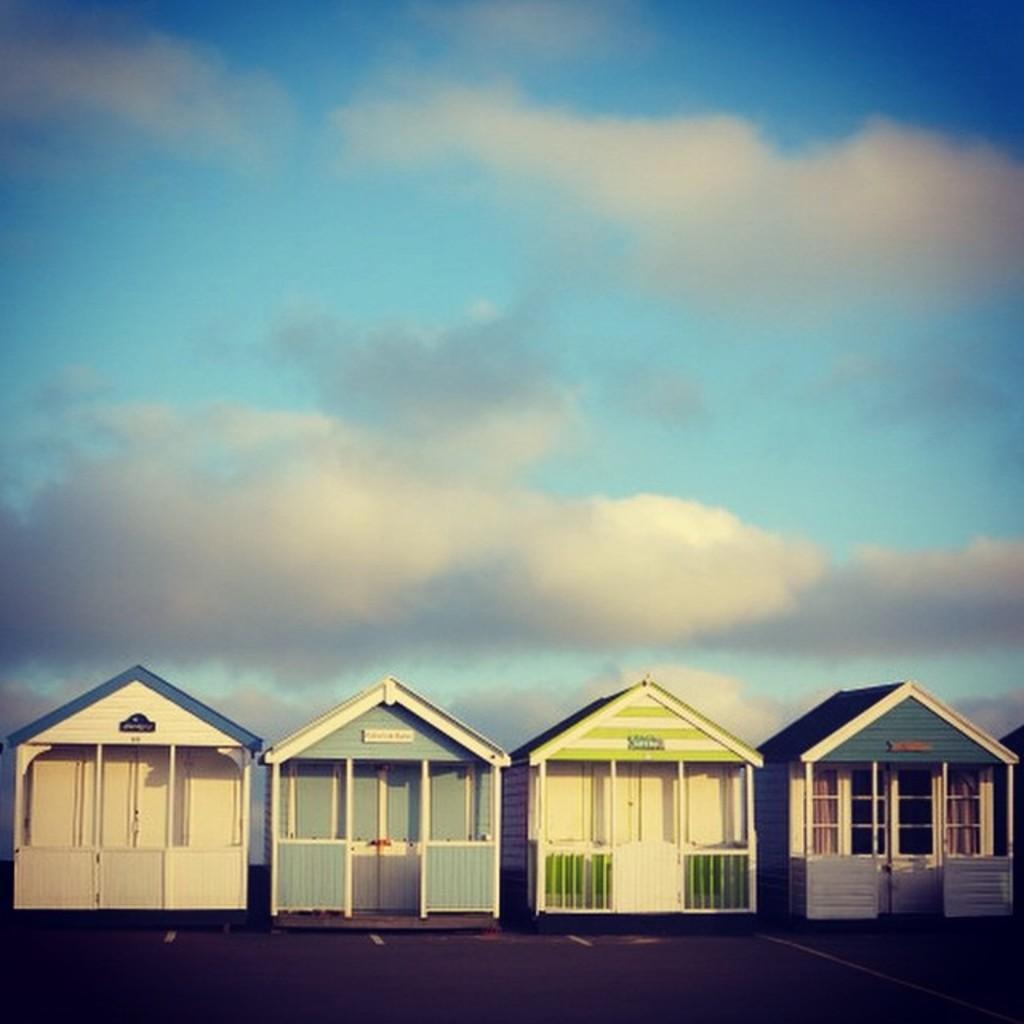Can you describe this image briefly? In this image there are four wooden houses, at the top of the image there are clouds in the sky. 